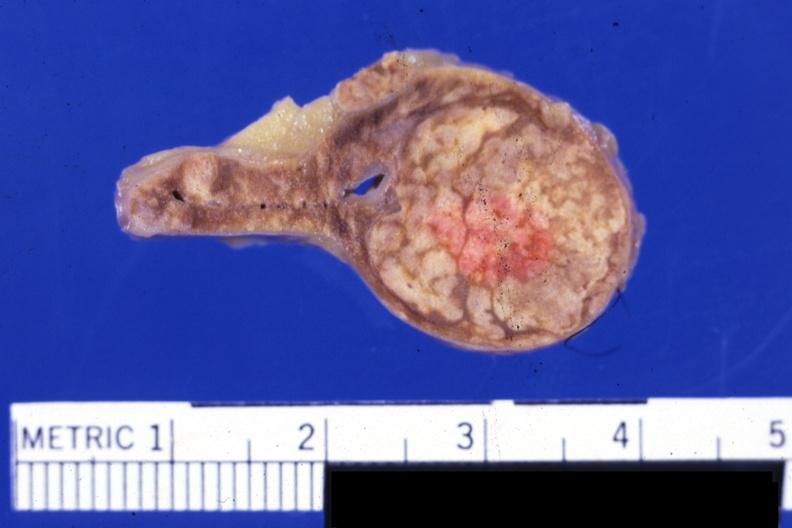what is present?
Answer the question using a single word or phrase. Cortical nodule 